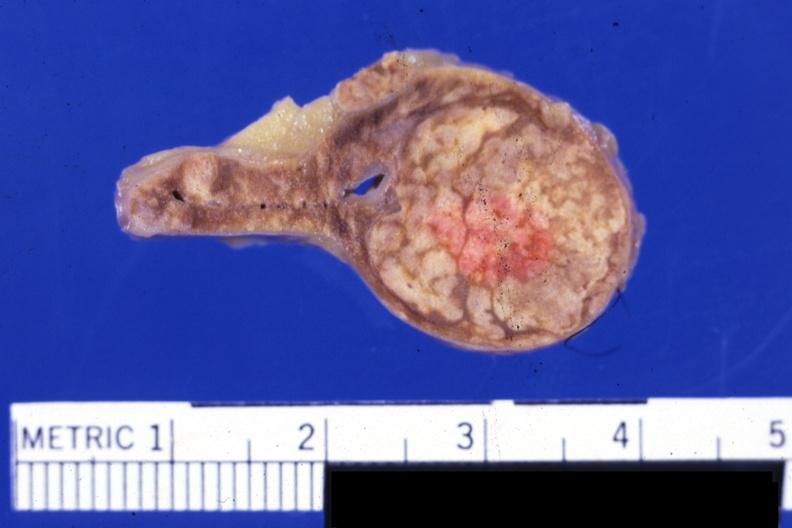what is present?
Answer the question using a single word or phrase. Cortical nodule 